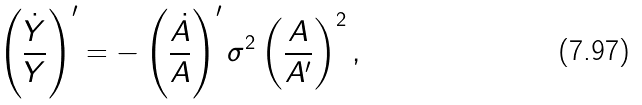Convert formula to latex. <formula><loc_0><loc_0><loc_500><loc_500>\left ( \frac { \dot { Y } } { Y } \right ) ^ { \prime } = - \left ( \frac { \dot { A } } { A } \right ) ^ { \prime } \sigma ^ { 2 } \left ( \frac { A } { A ^ { \prime } } \right ) ^ { 2 } ,</formula> 